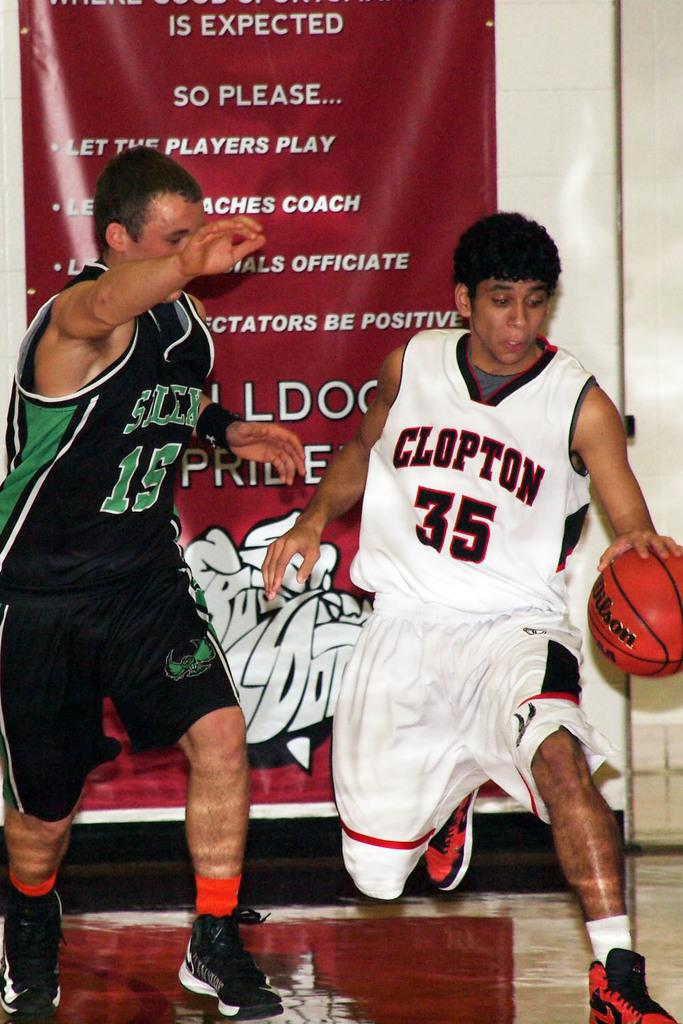<image>
Describe the image concisely. Two men are playing basketball and one has the word clopton on his jersey. 